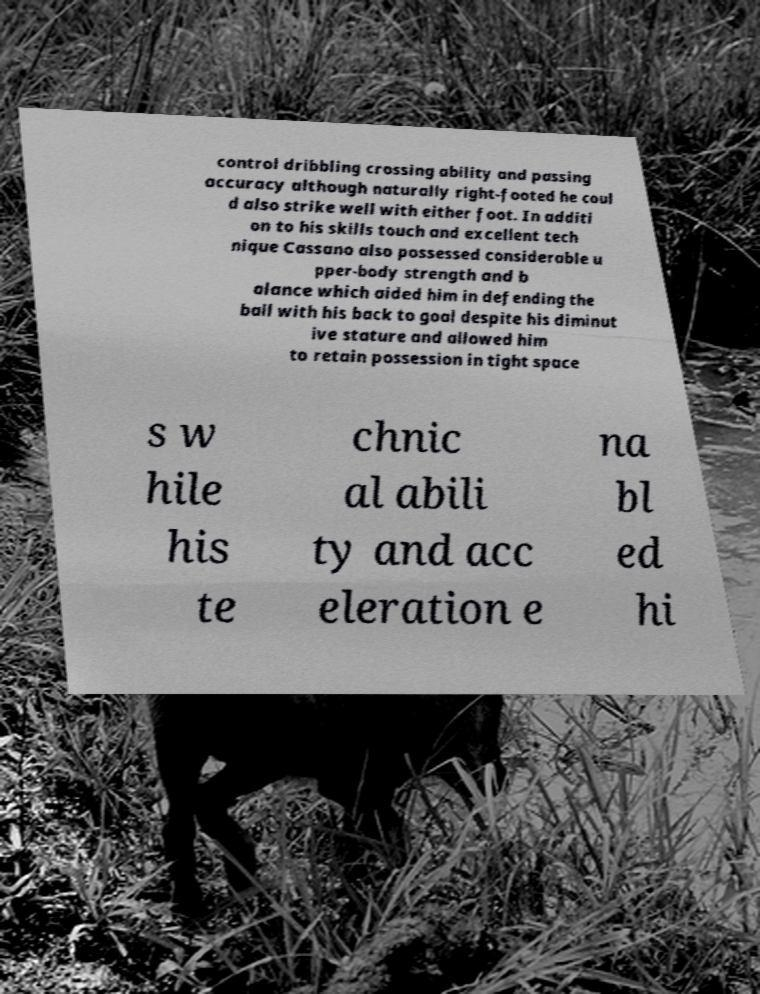I need the written content from this picture converted into text. Can you do that? control dribbling crossing ability and passing accuracy although naturally right-footed he coul d also strike well with either foot. In additi on to his skills touch and excellent tech nique Cassano also possessed considerable u pper-body strength and b alance which aided him in defending the ball with his back to goal despite his diminut ive stature and allowed him to retain possession in tight space s w hile his te chnic al abili ty and acc eleration e na bl ed hi 